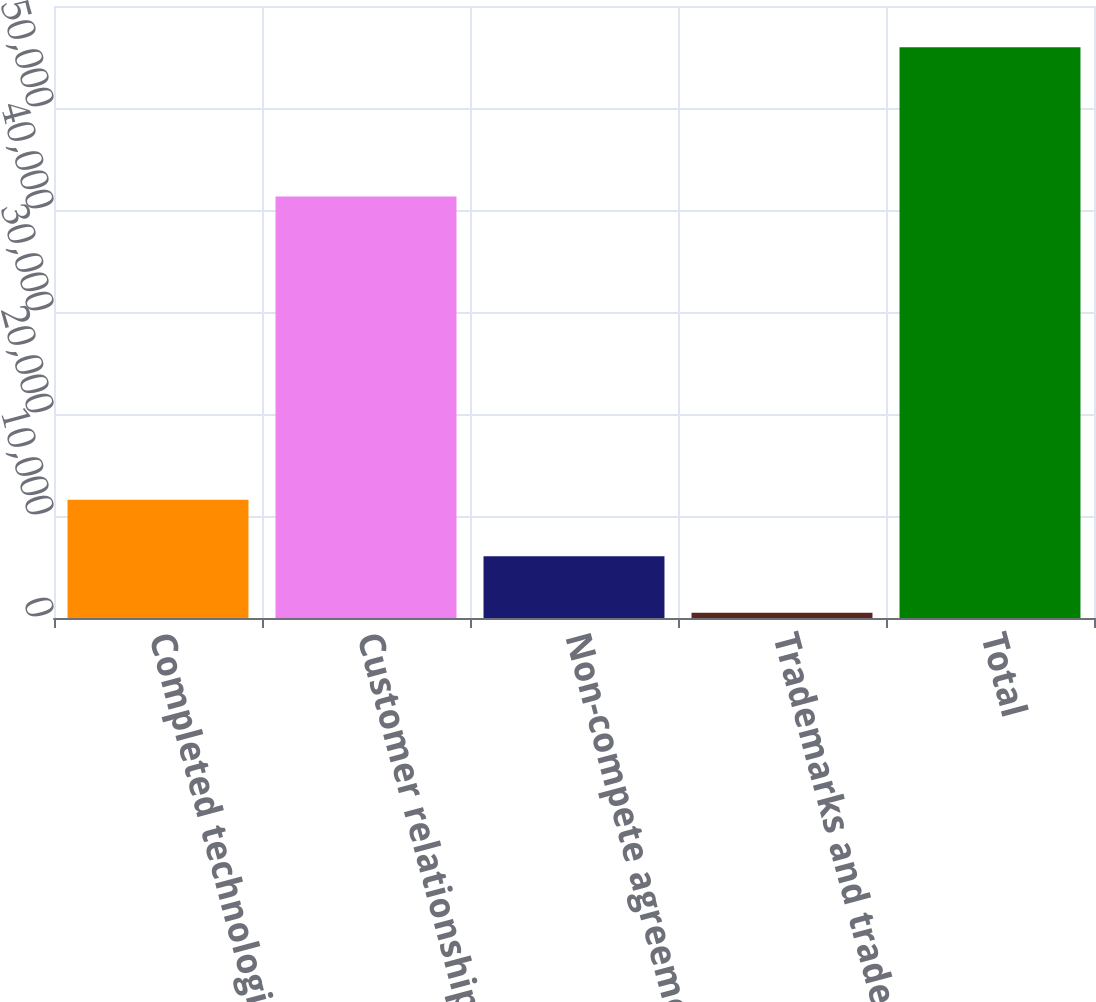<chart> <loc_0><loc_0><loc_500><loc_500><bar_chart><fcel>Completed technologies<fcel>Customer relationships<fcel>Non-compete agreements<fcel>Trademarks and trade names<fcel>Total<nl><fcel>11593.6<fcel>41312<fcel>6049.3<fcel>505<fcel>55948<nl></chart> 